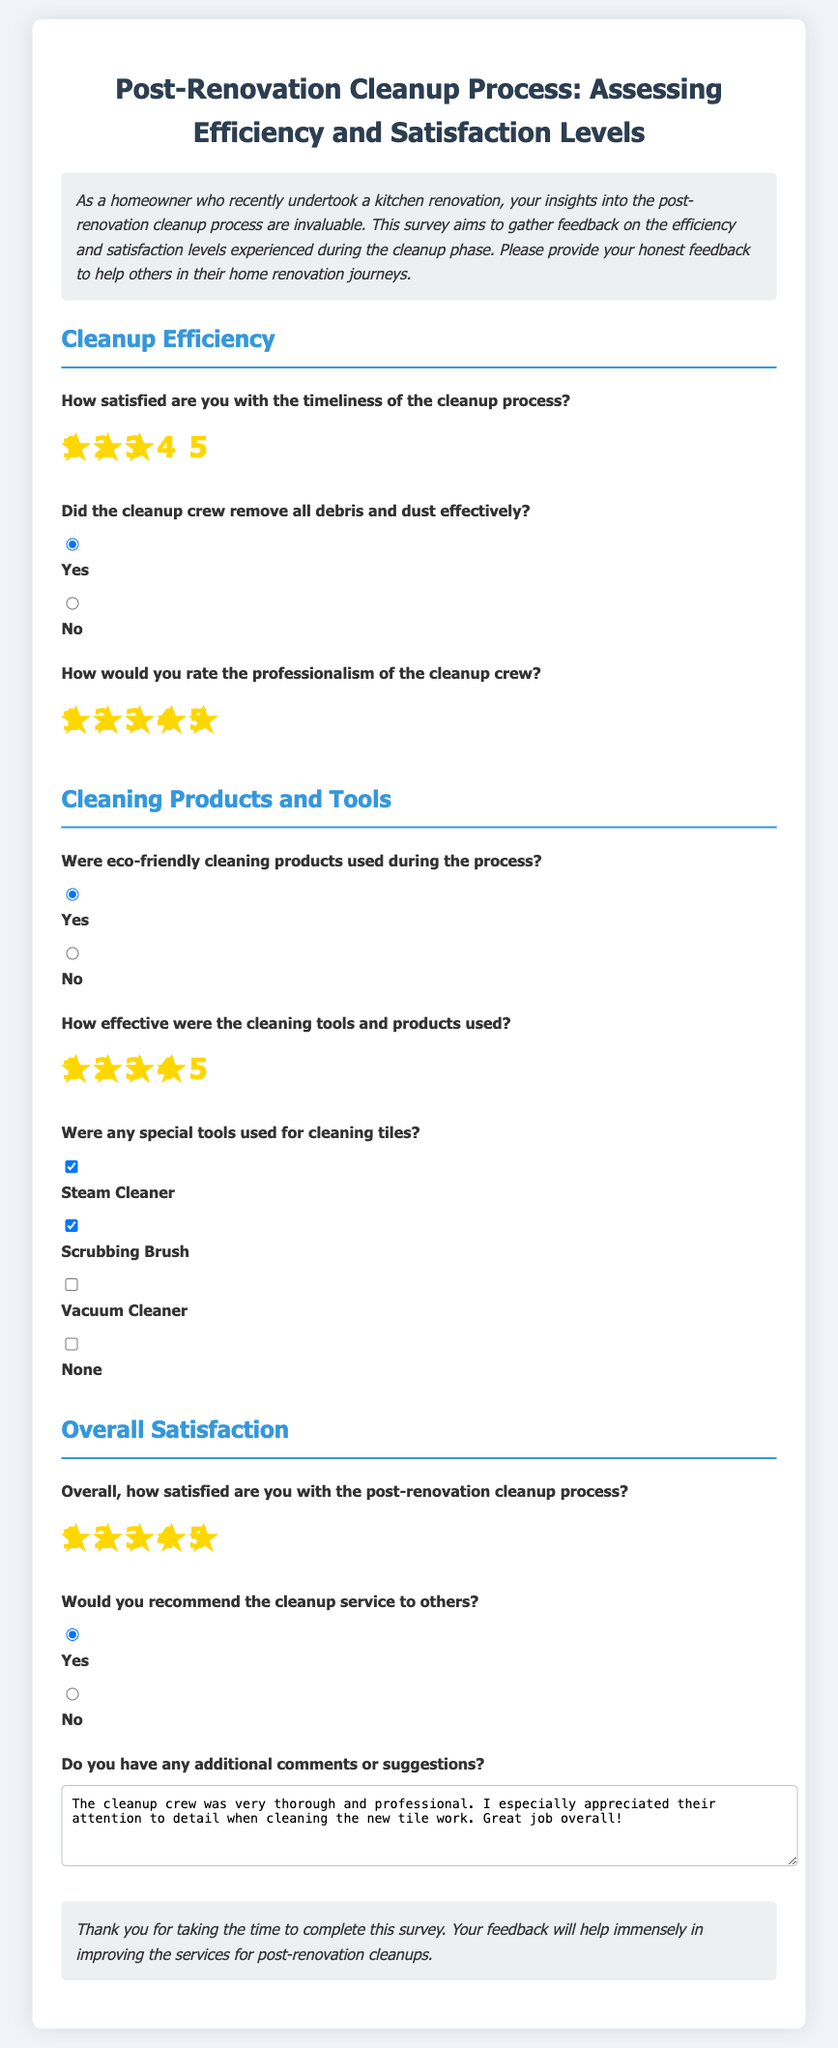How satisfied are you with the timeliness of the cleanup process? This question aims to gauge the respondent's satisfaction level regarding how quickly the cleanup was performed, and it presents a rating scale from 1 to 5.
Answer: 3 Did the cleanup crew remove all debris and dust effectively? This question checks if the cleanup crew completed their task of removing debris and dust, providing a yes or no response option.
Answer: Yes How would you rate the professionalism of the cleanup crew? This question seeks feedback on the professionalism, again using a rating scale from 1 to 5, reflecting the quality of service.
Answer: 5 Were eco-friendly cleaning products used during the process? This question identifies whether the cleaning products were environmentally friendly, offering a simple yes or no choice.
Answer: Yes Overall, how satisfied are you with the post-renovation cleanup process? This question captures the overall satisfaction level with the cleanup on a scale from 1 to 5, summarizing the respondent's experience.
Answer: 5 Would you recommend the cleanup service to others? This question evaluates whether the respondent would suggest the service to others, with a straightforward yes or no response.
Answer: Yes Do you have any additional comments or suggestions? This question invites open-ended feedback or suggestions, providing space for any further insights captured by the respondent.
Answer: The cleanup crew was very thorough and professional. I especially appreciated their attention to detail when cleaning the new tile work. Great job overall! 